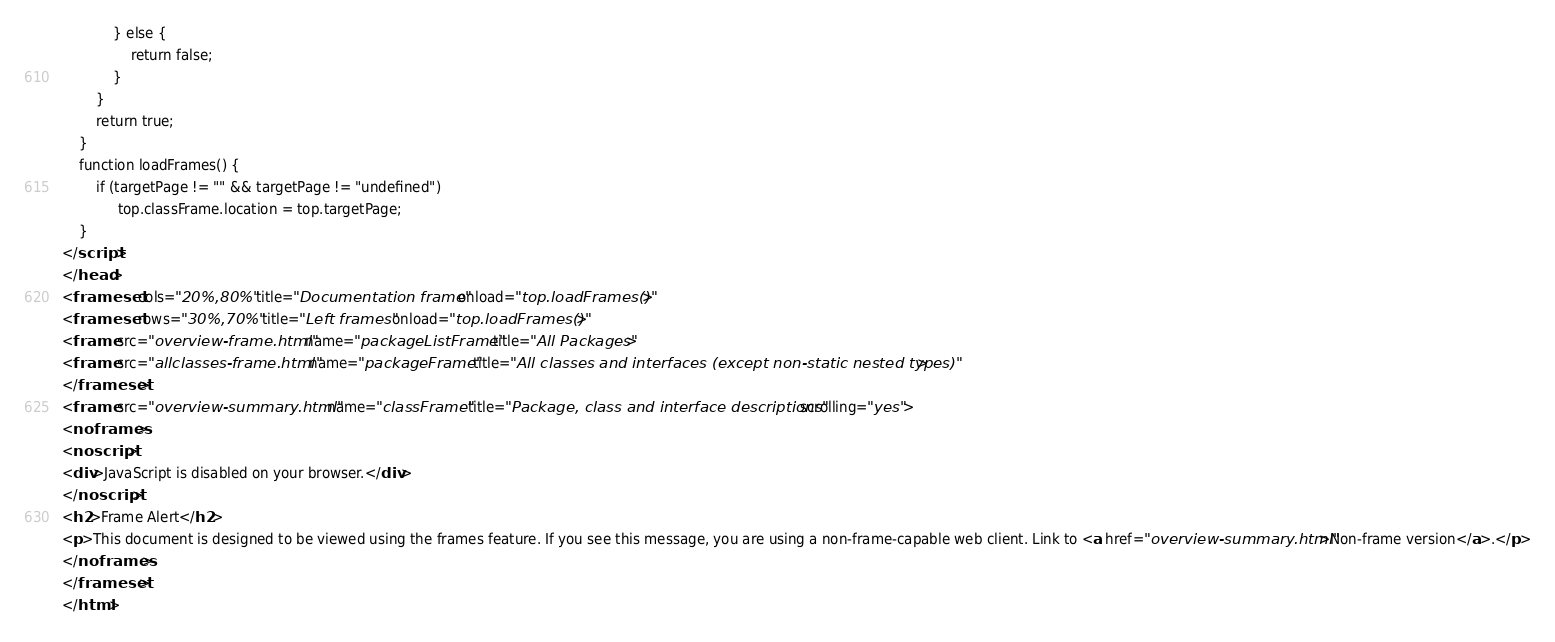<code> <loc_0><loc_0><loc_500><loc_500><_HTML_>            } else {
                return false;
            }
        }
        return true;
    }
    function loadFrames() {
        if (targetPage != "" && targetPage != "undefined")
             top.classFrame.location = top.targetPage;
    }
</script>
</head>
<frameset cols="20%,80%" title="Documentation frame" onload="top.loadFrames()">
<frameset rows="30%,70%" title="Left frames" onload="top.loadFrames()">
<frame src="overview-frame.html" name="packageListFrame" title="All Packages">
<frame src="allclasses-frame.html" name="packageFrame" title="All classes and interfaces (except non-static nested types)">
</frameset>
<frame src="overview-summary.html" name="classFrame" title="Package, class and interface descriptions" scrolling="yes">
<noframes>
<noscript>
<div>JavaScript is disabled on your browser.</div>
</noscript>
<h2>Frame Alert</h2>
<p>This document is designed to be viewed using the frames feature. If you see this message, you are using a non-frame-capable web client. Link to <a href="overview-summary.html">Non-frame version</a>.</p>
</noframes>
</frameset>
</html>
</code> 